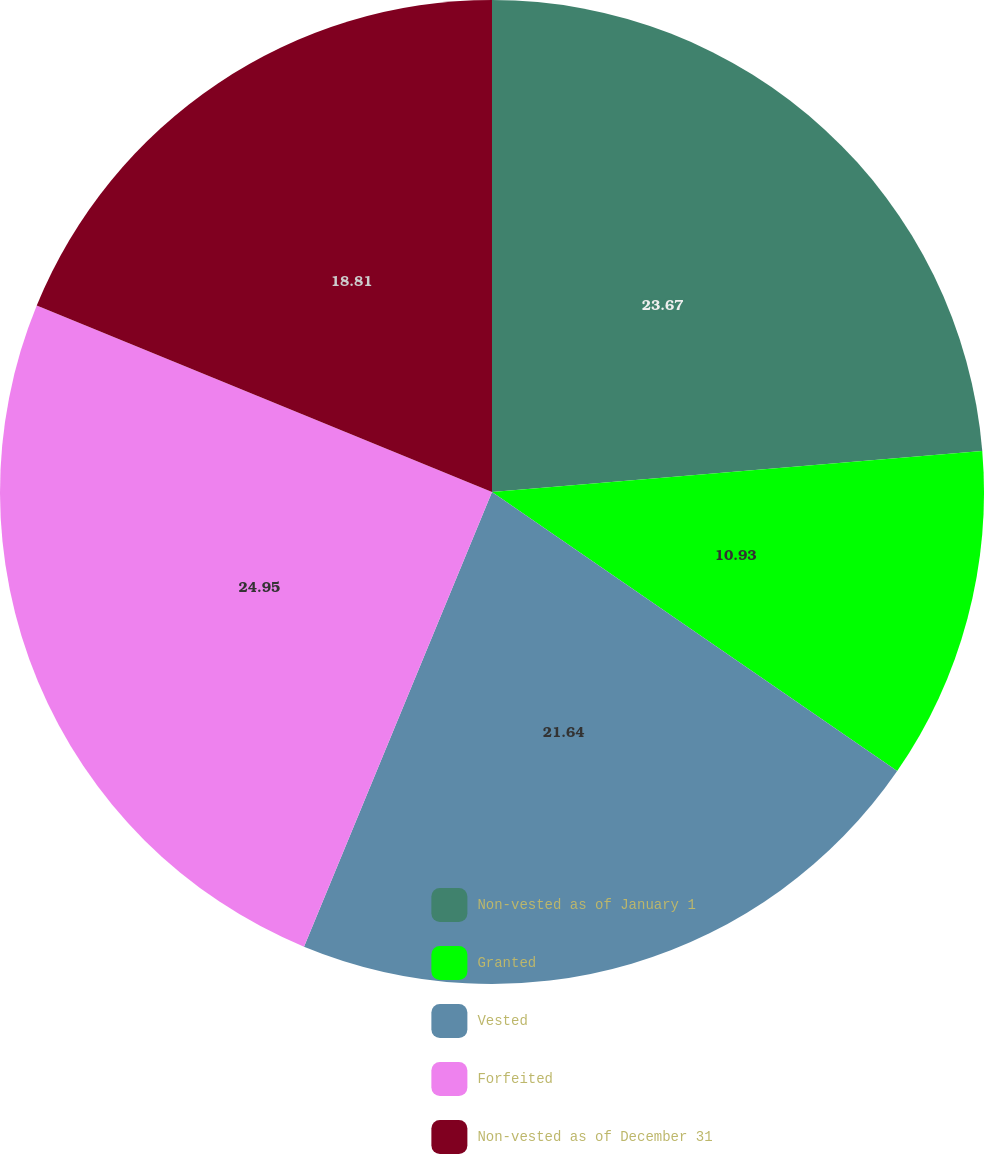Convert chart to OTSL. <chart><loc_0><loc_0><loc_500><loc_500><pie_chart><fcel>Non-vested as of January 1<fcel>Granted<fcel>Vested<fcel>Forfeited<fcel>Non-vested as of December 31<nl><fcel>23.67%<fcel>10.93%<fcel>21.64%<fcel>24.95%<fcel>18.81%<nl></chart> 